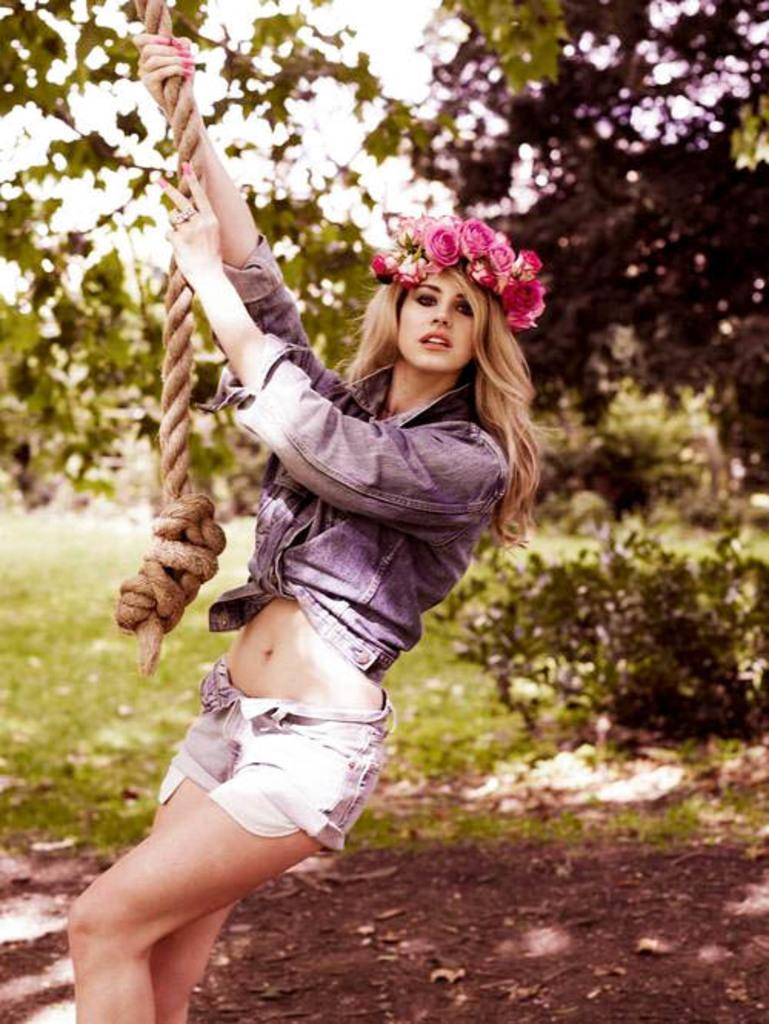What is the main subject in the foreground of the picture? There is a woman in the foreground of the picture. What is the woman holding in the picture? The woman is holding a rope. What type of terrain is visible in the foreground of the picture? There is mud in the foreground of the picture. What can be seen in the background of the picture? Trees, plants, and grass are visible in the background of the picture. How many giants are visible in the picture? There are no giants present in the image. What type of blade is being used by the woman in the picture? There is no blade visible in the picture; the woman is holding a rope. 